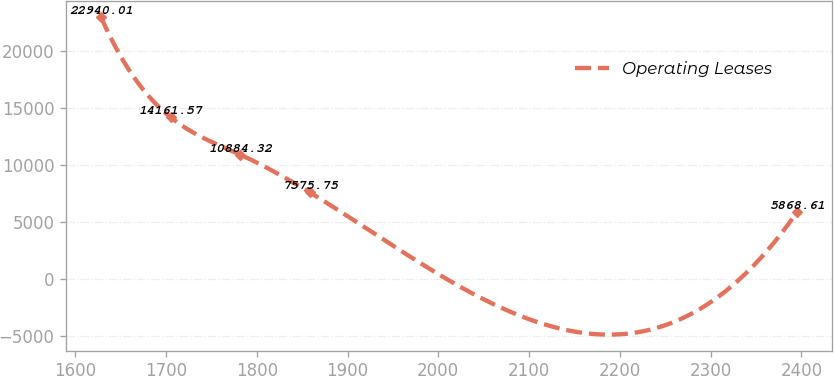Convert chart to OTSL. <chart><loc_0><loc_0><loc_500><loc_500><line_chart><ecel><fcel>Operating Leases<nl><fcel>1628.4<fcel>22940<nl><fcel>1705.09<fcel>14161.6<nl><fcel>1781.78<fcel>10884.3<nl><fcel>1858.47<fcel>7575.75<nl><fcel>2395.28<fcel>5868.61<nl></chart> 